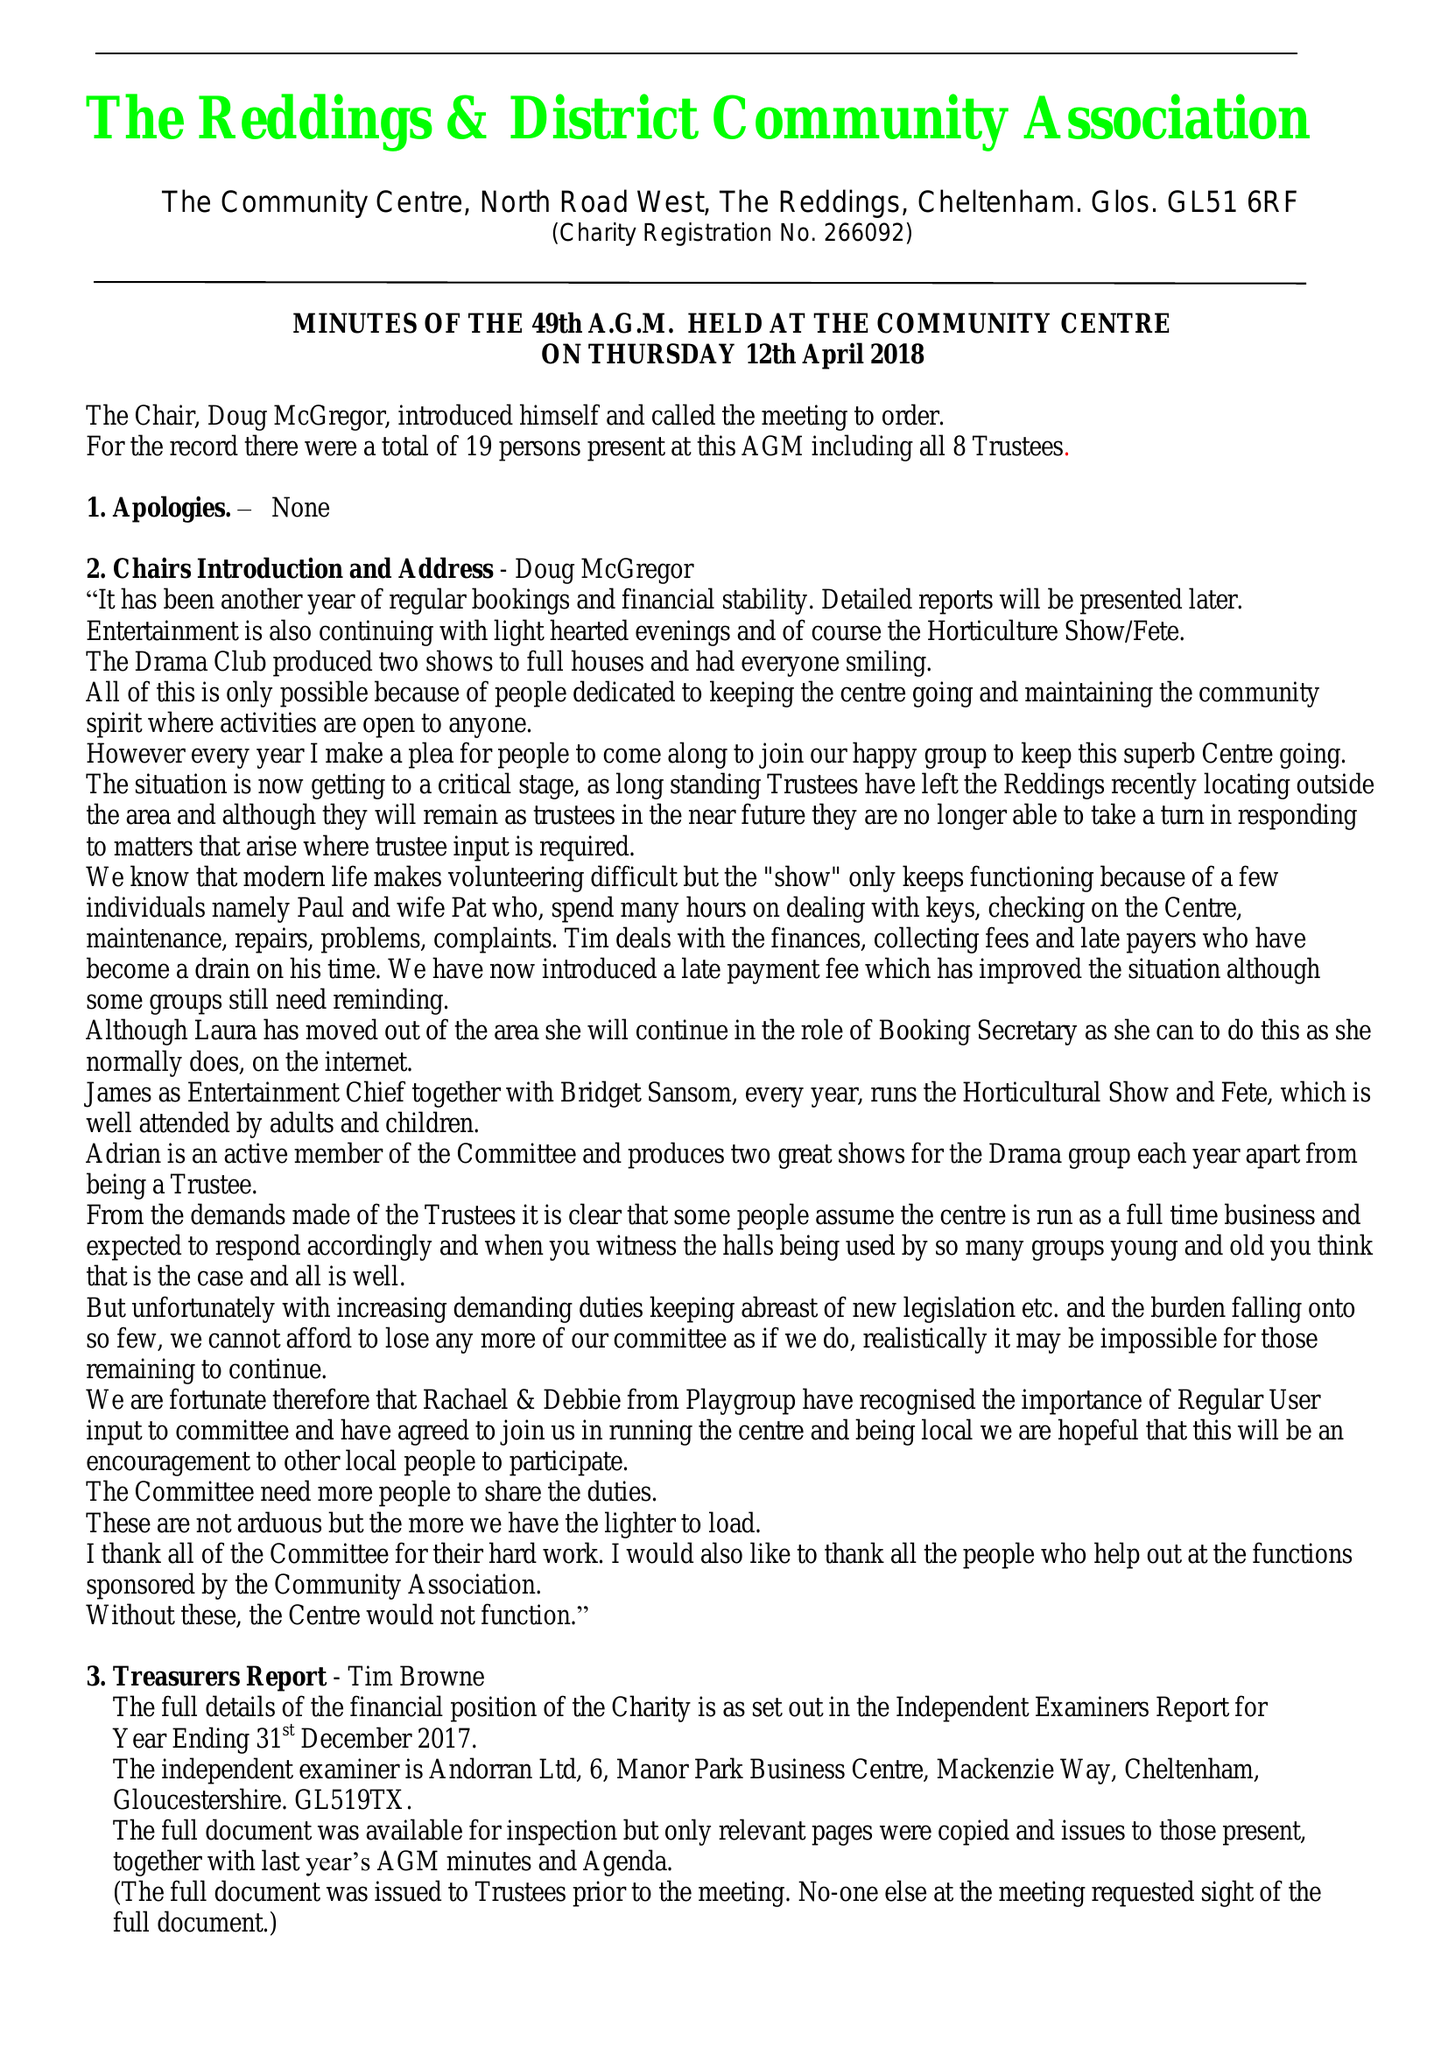What is the value for the charity_number?
Answer the question using a single word or phrase. 266092 